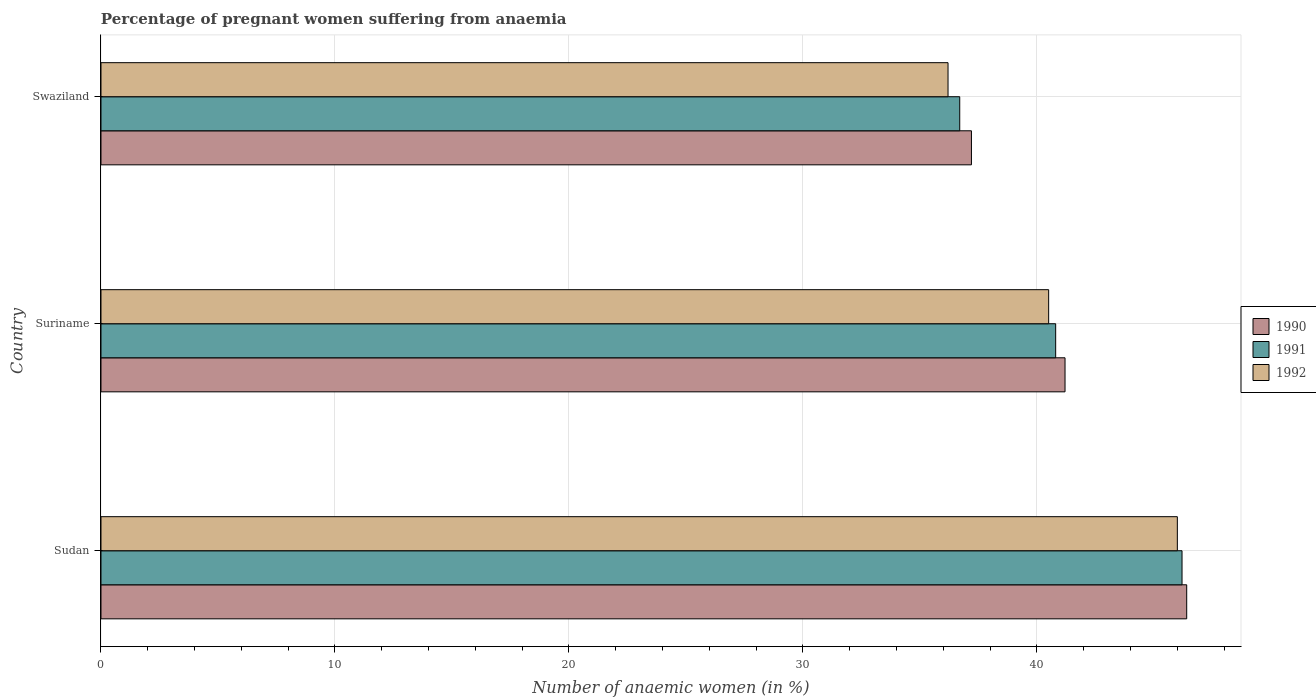How many groups of bars are there?
Give a very brief answer. 3. Are the number of bars per tick equal to the number of legend labels?
Keep it short and to the point. Yes. Are the number of bars on each tick of the Y-axis equal?
Give a very brief answer. Yes. What is the label of the 2nd group of bars from the top?
Your answer should be compact. Suriname. What is the number of anaemic women in 1990 in Suriname?
Make the answer very short. 41.2. Across all countries, what is the maximum number of anaemic women in 1990?
Offer a terse response. 46.4. Across all countries, what is the minimum number of anaemic women in 1990?
Your answer should be very brief. 37.2. In which country was the number of anaemic women in 1991 maximum?
Your answer should be very brief. Sudan. In which country was the number of anaemic women in 1992 minimum?
Make the answer very short. Swaziland. What is the total number of anaemic women in 1990 in the graph?
Provide a short and direct response. 124.8. What is the difference between the number of anaemic women in 1991 in Sudan and the number of anaemic women in 1990 in Suriname?
Provide a succinct answer. 5. What is the average number of anaemic women in 1992 per country?
Your response must be concise. 40.9. What is the difference between the number of anaemic women in 1991 and number of anaemic women in 1992 in Sudan?
Your response must be concise. 0.2. What is the ratio of the number of anaemic women in 1991 in Suriname to that in Swaziland?
Offer a terse response. 1.11. Is the number of anaemic women in 1991 in Sudan less than that in Swaziland?
Your response must be concise. No. What is the difference between the highest and the lowest number of anaemic women in 1992?
Provide a succinct answer. 9.8. Is the sum of the number of anaemic women in 1990 in Suriname and Swaziland greater than the maximum number of anaemic women in 1992 across all countries?
Provide a short and direct response. Yes. What does the 1st bar from the top in Swaziland represents?
Your response must be concise. 1992. What does the 1st bar from the bottom in Sudan represents?
Offer a terse response. 1990. How many bars are there?
Keep it short and to the point. 9. How many countries are there in the graph?
Keep it short and to the point. 3. What is the difference between two consecutive major ticks on the X-axis?
Provide a short and direct response. 10. Does the graph contain any zero values?
Keep it short and to the point. No. Does the graph contain grids?
Ensure brevity in your answer.  Yes. Where does the legend appear in the graph?
Offer a terse response. Center right. What is the title of the graph?
Keep it short and to the point. Percentage of pregnant women suffering from anaemia. Does "1989" appear as one of the legend labels in the graph?
Give a very brief answer. No. What is the label or title of the X-axis?
Your response must be concise. Number of anaemic women (in %). What is the Number of anaemic women (in %) of 1990 in Sudan?
Your answer should be very brief. 46.4. What is the Number of anaemic women (in %) in 1991 in Sudan?
Provide a short and direct response. 46.2. What is the Number of anaemic women (in %) in 1992 in Sudan?
Provide a succinct answer. 46. What is the Number of anaemic women (in %) of 1990 in Suriname?
Provide a short and direct response. 41.2. What is the Number of anaemic women (in %) in 1991 in Suriname?
Provide a short and direct response. 40.8. What is the Number of anaemic women (in %) in 1992 in Suriname?
Give a very brief answer. 40.5. What is the Number of anaemic women (in %) in 1990 in Swaziland?
Offer a terse response. 37.2. What is the Number of anaemic women (in %) in 1991 in Swaziland?
Give a very brief answer. 36.7. What is the Number of anaemic women (in %) of 1992 in Swaziland?
Offer a very short reply. 36.2. Across all countries, what is the maximum Number of anaemic women (in %) of 1990?
Your response must be concise. 46.4. Across all countries, what is the maximum Number of anaemic women (in %) of 1991?
Provide a short and direct response. 46.2. Across all countries, what is the minimum Number of anaemic women (in %) of 1990?
Give a very brief answer. 37.2. Across all countries, what is the minimum Number of anaemic women (in %) of 1991?
Give a very brief answer. 36.7. Across all countries, what is the minimum Number of anaemic women (in %) of 1992?
Make the answer very short. 36.2. What is the total Number of anaemic women (in %) of 1990 in the graph?
Your answer should be very brief. 124.8. What is the total Number of anaemic women (in %) in 1991 in the graph?
Your answer should be compact. 123.7. What is the total Number of anaemic women (in %) in 1992 in the graph?
Offer a terse response. 122.7. What is the difference between the Number of anaemic women (in %) of 1990 in Sudan and that in Suriname?
Your answer should be compact. 5.2. What is the difference between the Number of anaemic women (in %) in 1990 in Sudan and that in Swaziland?
Your response must be concise. 9.2. What is the difference between the Number of anaemic women (in %) in 1991 in Sudan and that in Swaziland?
Give a very brief answer. 9.5. What is the difference between the Number of anaemic women (in %) of 1990 in Suriname and that in Swaziland?
Keep it short and to the point. 4. What is the difference between the Number of anaemic women (in %) of 1992 in Suriname and that in Swaziland?
Your answer should be very brief. 4.3. What is the difference between the Number of anaemic women (in %) in 1991 in Sudan and the Number of anaemic women (in %) in 1992 in Swaziland?
Your answer should be compact. 10. What is the difference between the Number of anaemic women (in %) of 1990 in Suriname and the Number of anaemic women (in %) of 1991 in Swaziland?
Offer a very short reply. 4.5. What is the average Number of anaemic women (in %) of 1990 per country?
Ensure brevity in your answer.  41.6. What is the average Number of anaemic women (in %) of 1991 per country?
Your answer should be compact. 41.23. What is the average Number of anaemic women (in %) of 1992 per country?
Make the answer very short. 40.9. What is the difference between the Number of anaemic women (in %) of 1990 and Number of anaemic women (in %) of 1992 in Sudan?
Offer a terse response. 0.4. What is the difference between the Number of anaemic women (in %) of 1991 and Number of anaemic women (in %) of 1992 in Sudan?
Make the answer very short. 0.2. What is the difference between the Number of anaemic women (in %) in 1990 and Number of anaemic women (in %) in 1991 in Suriname?
Provide a succinct answer. 0.4. What is the difference between the Number of anaemic women (in %) in 1990 and Number of anaemic women (in %) in 1992 in Suriname?
Offer a very short reply. 0.7. What is the difference between the Number of anaemic women (in %) in 1991 and Number of anaemic women (in %) in 1992 in Suriname?
Provide a short and direct response. 0.3. What is the ratio of the Number of anaemic women (in %) in 1990 in Sudan to that in Suriname?
Provide a succinct answer. 1.13. What is the ratio of the Number of anaemic women (in %) of 1991 in Sudan to that in Suriname?
Offer a terse response. 1.13. What is the ratio of the Number of anaemic women (in %) in 1992 in Sudan to that in Suriname?
Your answer should be compact. 1.14. What is the ratio of the Number of anaemic women (in %) in 1990 in Sudan to that in Swaziland?
Provide a short and direct response. 1.25. What is the ratio of the Number of anaemic women (in %) in 1991 in Sudan to that in Swaziland?
Make the answer very short. 1.26. What is the ratio of the Number of anaemic women (in %) in 1992 in Sudan to that in Swaziland?
Give a very brief answer. 1.27. What is the ratio of the Number of anaemic women (in %) in 1990 in Suriname to that in Swaziland?
Offer a very short reply. 1.11. What is the ratio of the Number of anaemic women (in %) in 1991 in Suriname to that in Swaziland?
Make the answer very short. 1.11. What is the ratio of the Number of anaemic women (in %) in 1992 in Suriname to that in Swaziland?
Ensure brevity in your answer.  1.12. What is the difference between the highest and the lowest Number of anaemic women (in %) of 1990?
Offer a terse response. 9.2. What is the difference between the highest and the lowest Number of anaemic women (in %) of 1992?
Your answer should be compact. 9.8. 